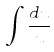<formula> <loc_0><loc_0><loc_500><loc_500>\int \frac { d u } { u }</formula> 